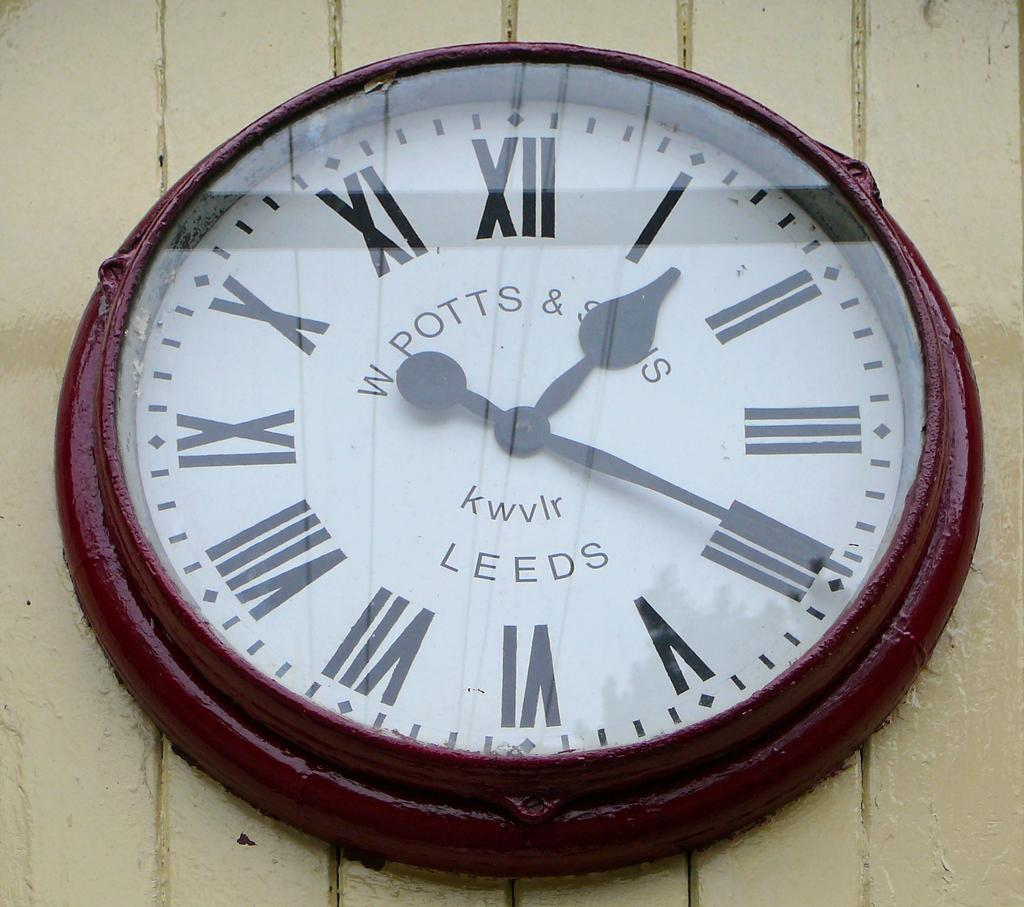<image>
Relay a brief, clear account of the picture shown. A W Potts and Son's clock displaying the time. 